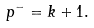Convert formula to latex. <formula><loc_0><loc_0><loc_500><loc_500>p ^ { - } = k + 1 .</formula> 